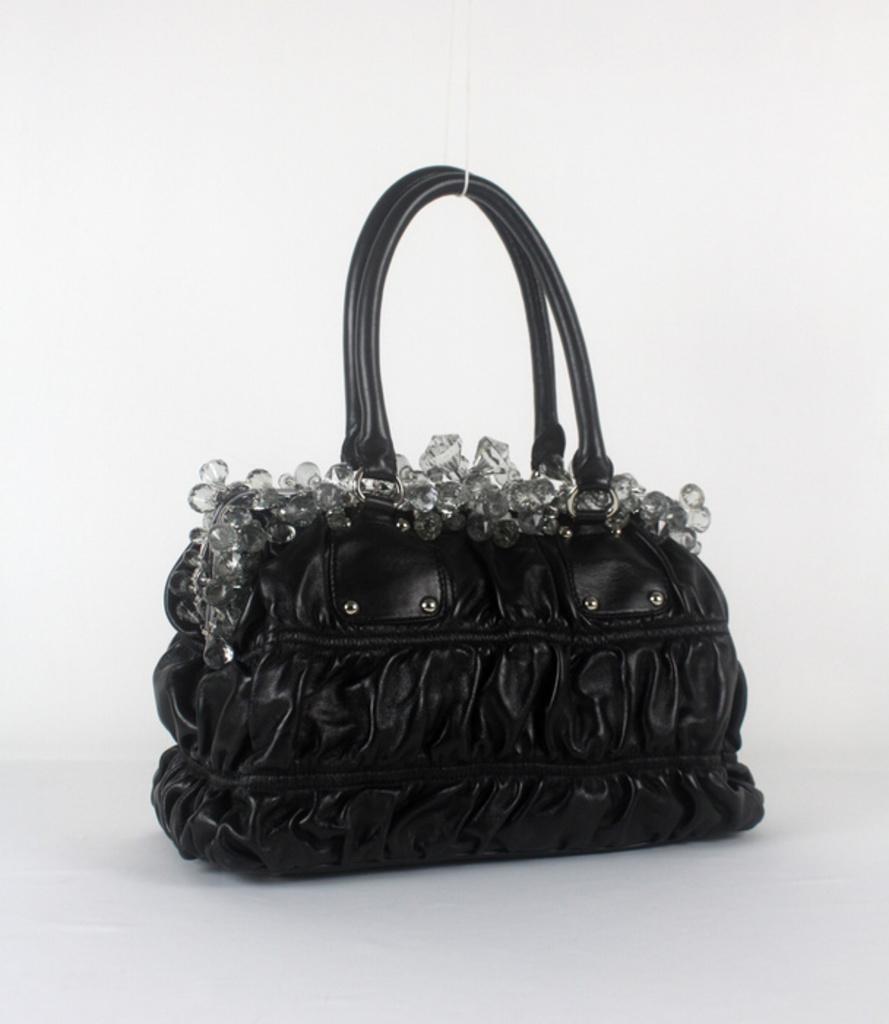Describe this image in one or two sentences. In this picture we can see a black color handbag. 